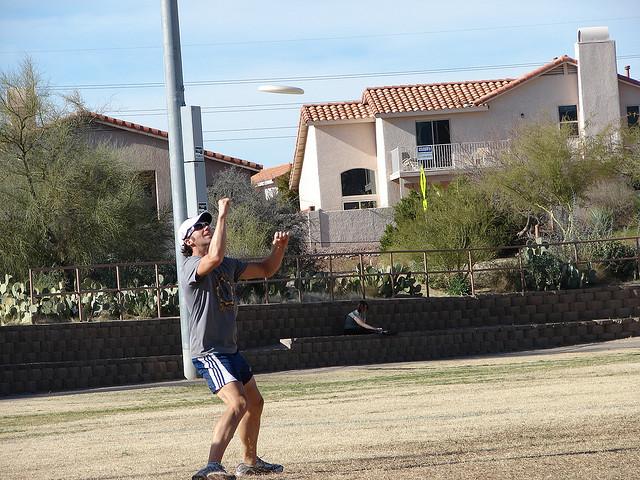Is the man wearing socks?
Quick response, please. No. What game is the person playing?
Give a very brief answer. Frisbee. What sport is the man playing?
Concise answer only. Frisbee. What kind of roof is on the house?
Quick response, please. Tile. 